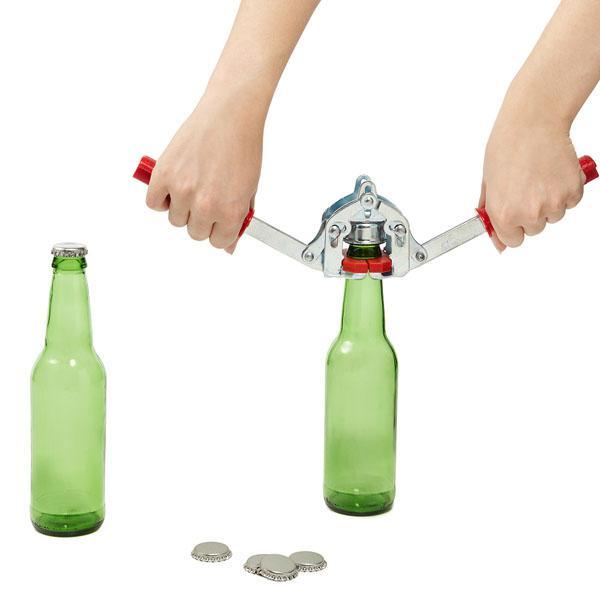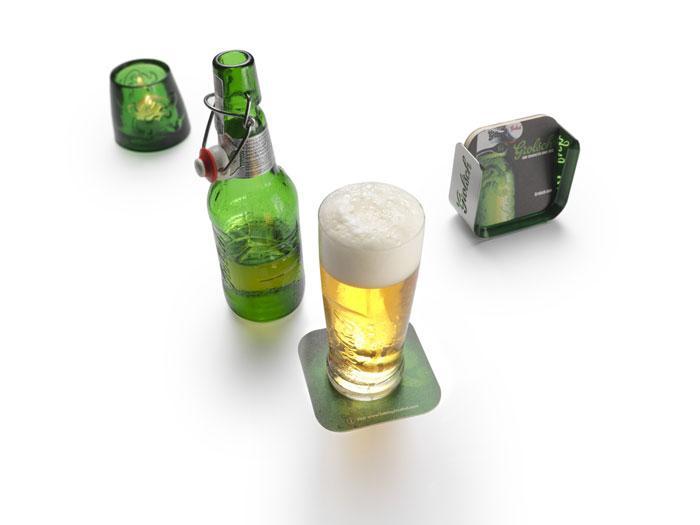The first image is the image on the left, the second image is the image on the right. For the images displayed, is the sentence "In one image, the bottles are capped and have distinctive matching labels, while the other image is of empty, uncapped bottles." factually correct? Answer yes or no. No. The first image is the image on the left, the second image is the image on the right. Examine the images to the left and right. Is the description "One image includes at least one glass containing beer, along with at least one beer bottle." accurate? Answer yes or no. Yes. The first image is the image on the left, the second image is the image on the right. Given the left and right images, does the statement "There are four green bottles in the left image." hold true? Answer yes or no. No. The first image is the image on the left, the second image is the image on the right. Considering the images on both sides, is "An image includes at least one green bottle displayed horizontally." valid? Answer yes or no. No. 